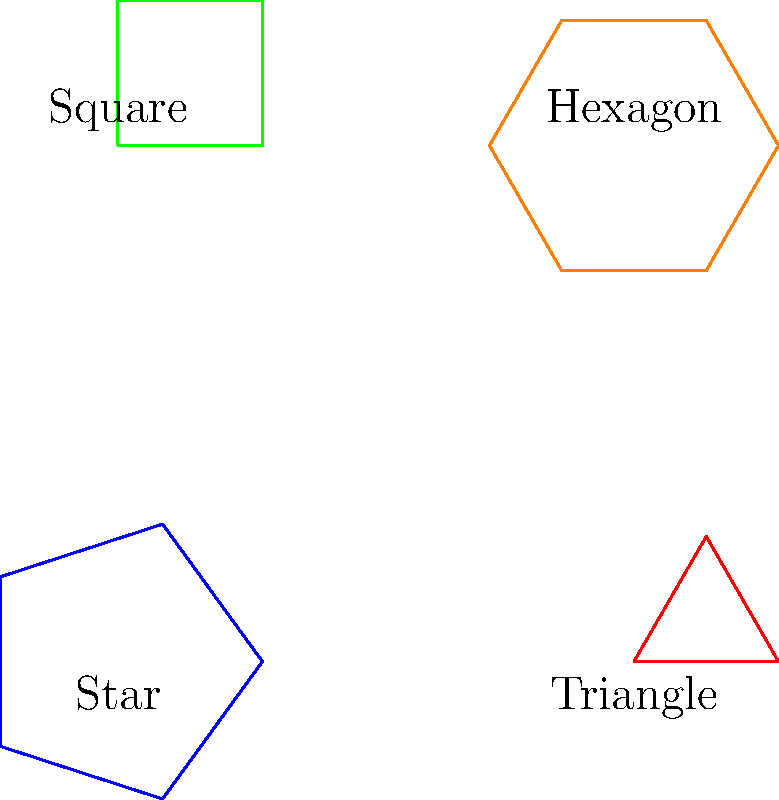Consider the set of geometric shapes representing diverse cultural symbols: a five-pointed star, an equilateral triangle, a square, and a regular hexagon. What is the order of the symmetry group for this entire set of shapes? To find the order of the symmetry group for the entire set, we need to follow these steps:

1. Determine the symmetry group of each shape:
   a) Five-pointed star: $D_5$ (dihedral group of order 10)
   b) Equilateral triangle: $D_3$ (dihedral group of order 6)
   c) Square: $D_4$ (dihedral group of order 8)
   d) Regular hexagon: $D_6$ (dihedral group of order 12)

2. The symmetry group of the entire set is the direct product of these individual groups:
   $G = D_5 \times D_3 \times D_4 \times D_6$

3. The order of a direct product is the product of the orders of its components:
   $|G| = |D_5| \times |D_3| \times |D_4| \times |D_6|$

4. Substitute the orders:
   $|G| = 10 \times 6 \times 8 \times 12$

5. Calculate the final result:
   $|G| = 5760$

Therefore, the order of the symmetry group for the entire set of shapes is 5760.
Answer: 5760 